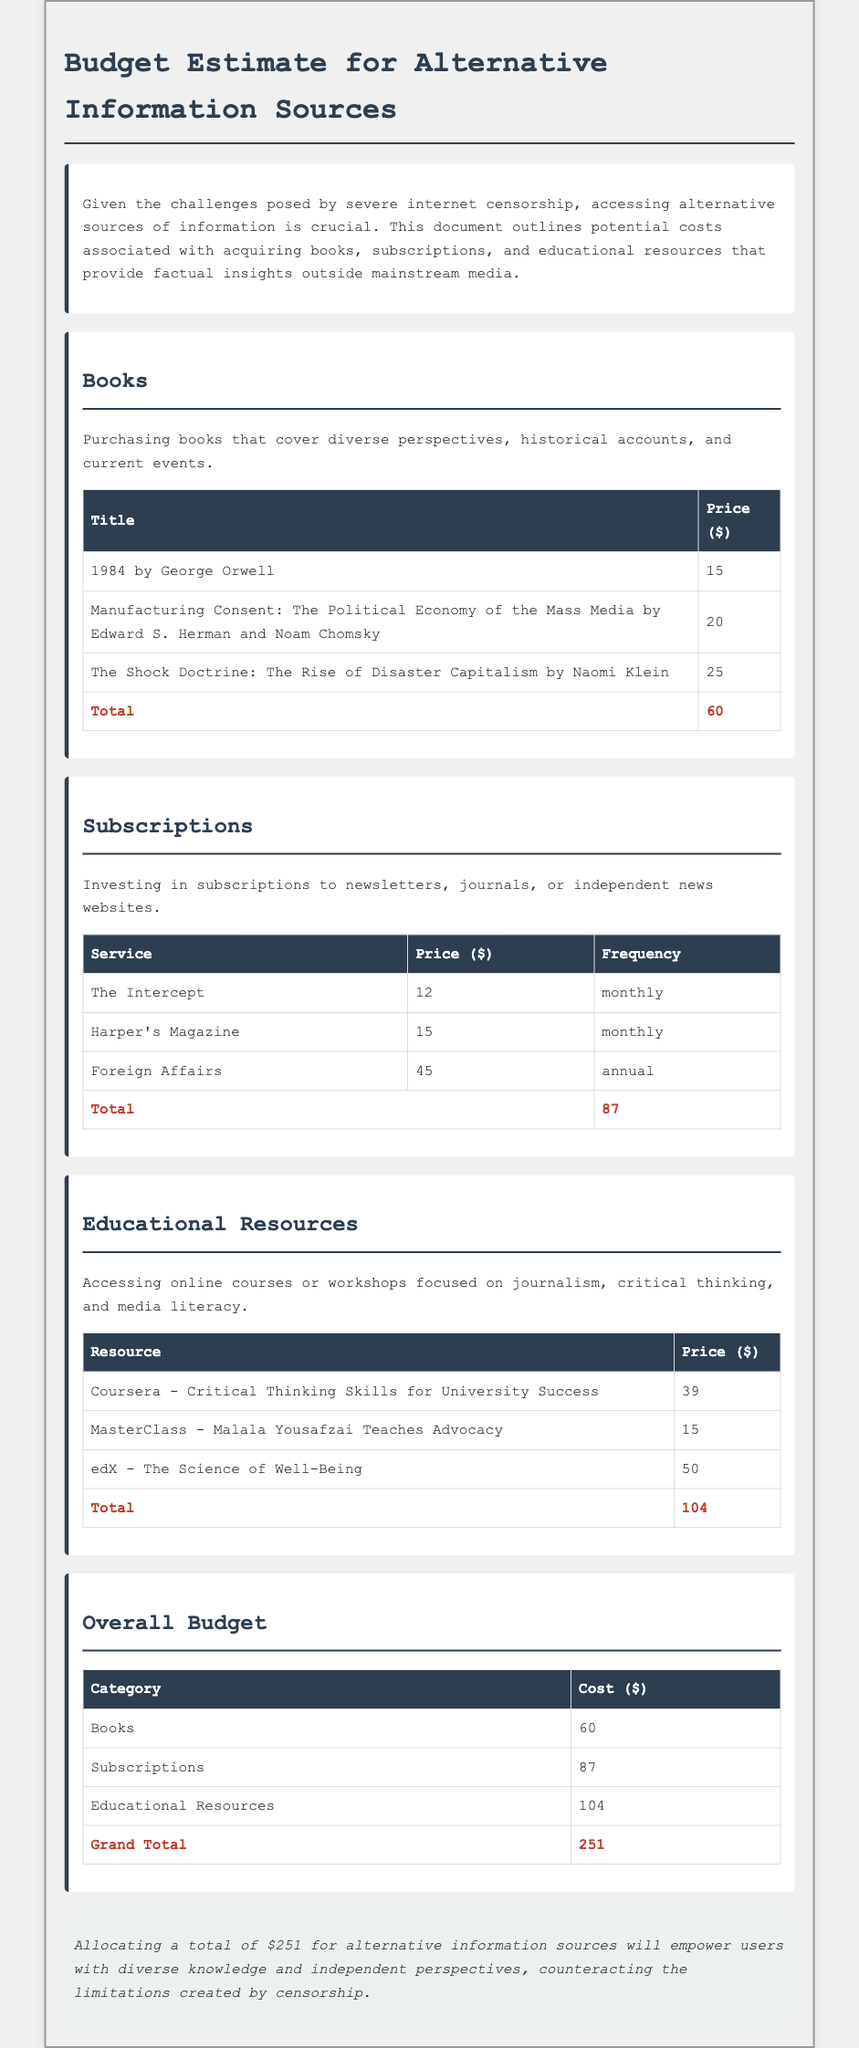What is the total cost for books? The total cost for books is calculated from the prices of individual books listed in the document, which sums up to $60.
Answer: $60 How much does a subscription to Harper's Magazine cost? The cost of a subscription to Harper's Magazine is specified in the subscriptions table as $15.
Answer: $15 What is the total budget allocated for educational resources? The total budget for educational resources is the sum of the prices of individual resources listed, which comes to $104.
Answer: $104 Which book by Naomi Klein is included in the budget estimate? The document includes "The Shock Doctrine: The Rise of Disaster Capitalism" by Naomi Klein in the books section.
Answer: The Shock Doctrine: The Rise of Disaster Capitalism What is the grand total of the overall budget? The grand total is the cumulative cost of books, subscriptions, and educational resources, equaling $251.
Answer: $251 How many educational resources are listed in the memo? The memo lists three educational resources in the section dedicated to them.
Answer: Three What is the monthly cost for The Intercept subscription? The monthly cost for The Intercept is stated in the subscriptions table as $12.
Answer: $12 What does the conclusion suggest about the total budget? The conclusion states that allocating a total of $251 empowers users with diverse knowledge to counteract censorship.
Answer: Diverse knowledge What is the frequency of the Foreign Affairs subscription? The frequency for Foreign Affairs subscription is given as annual in the subscriptions table.
Answer: Annual 